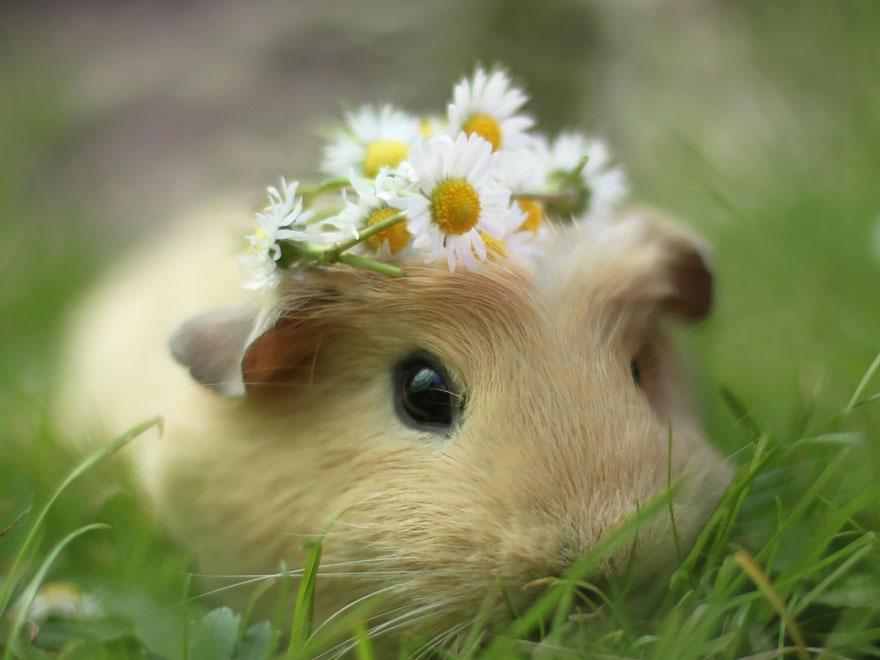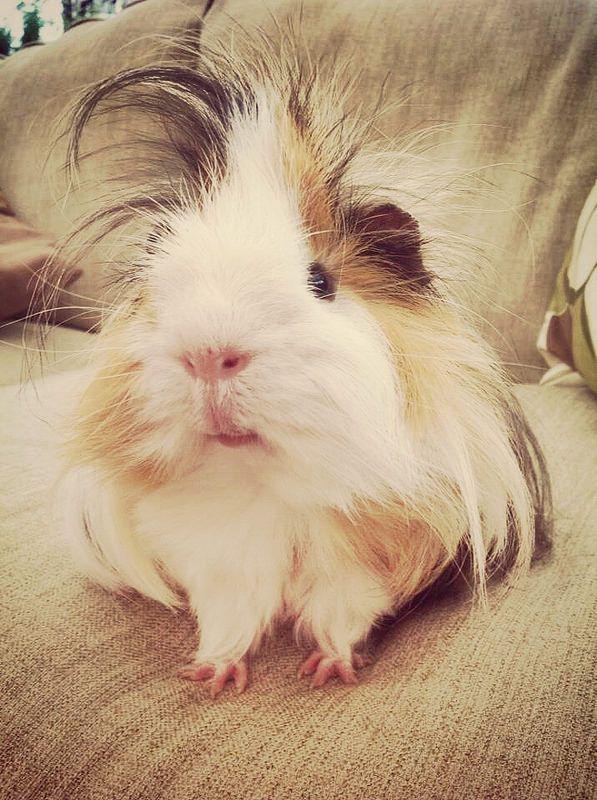The first image is the image on the left, the second image is the image on the right. Examine the images to the left and right. Is the description "An image shows just one hamster wearing something decorative on its head." accurate? Answer yes or no. Yes. 